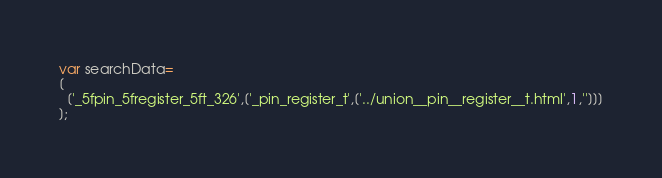Convert code to text. <code><loc_0><loc_0><loc_500><loc_500><_JavaScript_>var searchData=
[
  ['_5fpin_5fregister_5ft_326',['_pin_register_t',['../union__pin__register__t.html',1,'']]]
];
</code> 